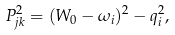Convert formula to latex. <formula><loc_0><loc_0><loc_500><loc_500>P _ { j k } ^ { 2 } = ( W _ { 0 } - \omega _ { i } ) ^ { 2 } - q _ { i } ^ { 2 } ,</formula> 